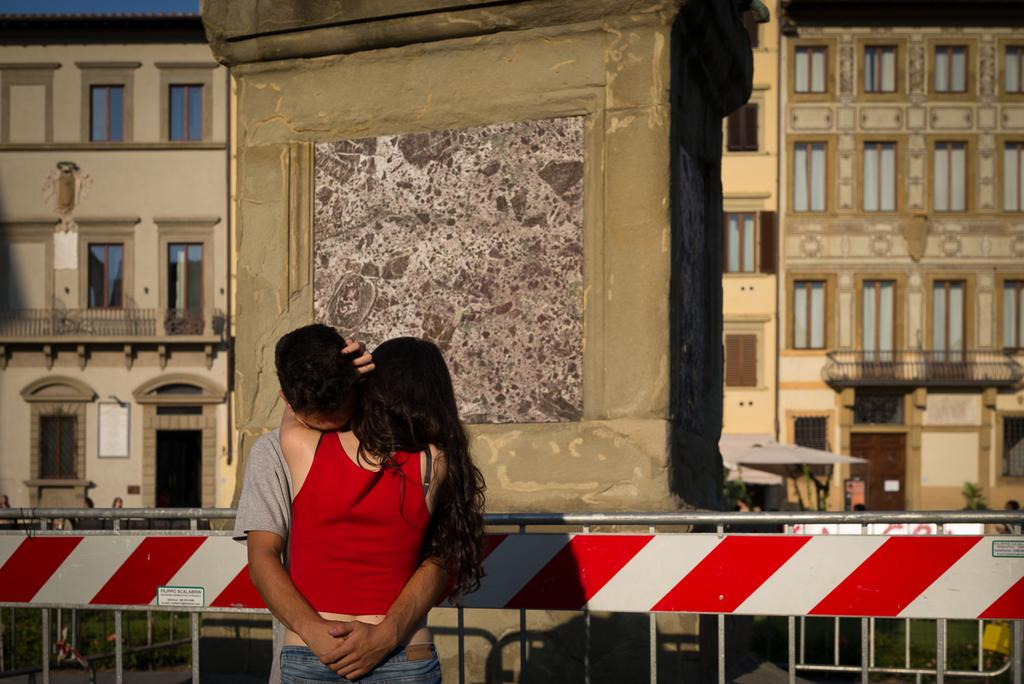How many people are in the image? There are two people in the image. What colors are the dresses worn by the people in the image? One person is wearing an ash-colored dress, one person is wearing a red-colored dress, and one person is wearing a blue-colored dress. What can be seen in the background of the image? There is a railing, a building with windows, and the sky visible in the background of the image. What type of cherry is being served for dinner in the image? There is no cherry or dinner present in the image. What societal issues are being discussed by the people in the image? The image does not provide any information about societal issues or discussions. 